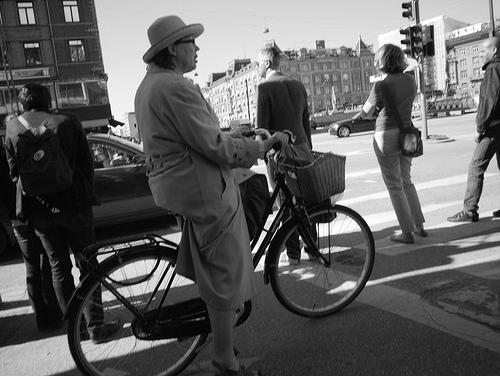Identify the primary subject of the image performing its activity. The primary subject is a woman on a bicycle, stopping at a crosswalk while awaiting her turn to cross. Provide a short depiction of the principal figure in the image and what they are involved in. There's an older woman cycling, pausing at a crosswalk as she waits for the signal to change. Express the main appearance in the image and the corresponding event. The main appearance is an elderly woman on a bicycle, paused at a crosswalk with other people and passing cars. State the main object in the picture and its situation. The main object is a woman on a bicycle, waiting at a crosswalk with other moving cars and people. Point out the main event and involved characters taking place in the image. The main event is an older woman on a bike waiting at a crosswalk, as cars drive by and people wait to cross. Indicate the most prominent individual in the photo along with their ongoing action. The most prominent individual is an older woman on a bike, waiting at a crosswalk amidst pedestrians and vehicles. What is the main focal point of the image and the action happening in it? An older woman riding a bicycle waits at the crosswalk, while other people and cars pass by on the street and sidewalk. Tell me the key subject in the photograph and their current action. The key subject is a woman on a bicycle, waiting to cross the street among passing traffic. Convey the primary element in the picture and describe what's happening. A senior woman rides a bicycle and temporarily stops at a crosswalk, surrounded by cars and pedestrians. Briefly describe the major activity happening in the image. An elderly woman on a bicycle is waiting at a crosswalk, as cars and pedestrians move around her. 